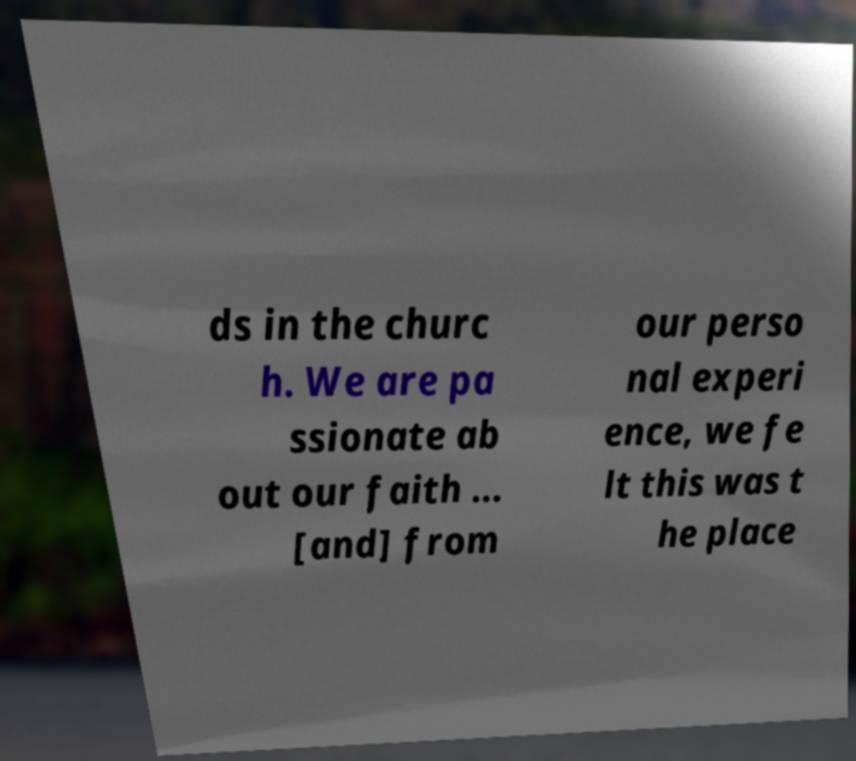Could you assist in decoding the text presented in this image and type it out clearly? ds in the churc h. We are pa ssionate ab out our faith ... [and] from our perso nal experi ence, we fe lt this was t he place 